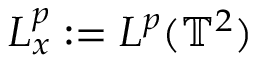<formula> <loc_0><loc_0><loc_500><loc_500>L _ { x } ^ { p } \colon = L ^ { p } ( \mathbb { T } ^ { 2 } )</formula> 